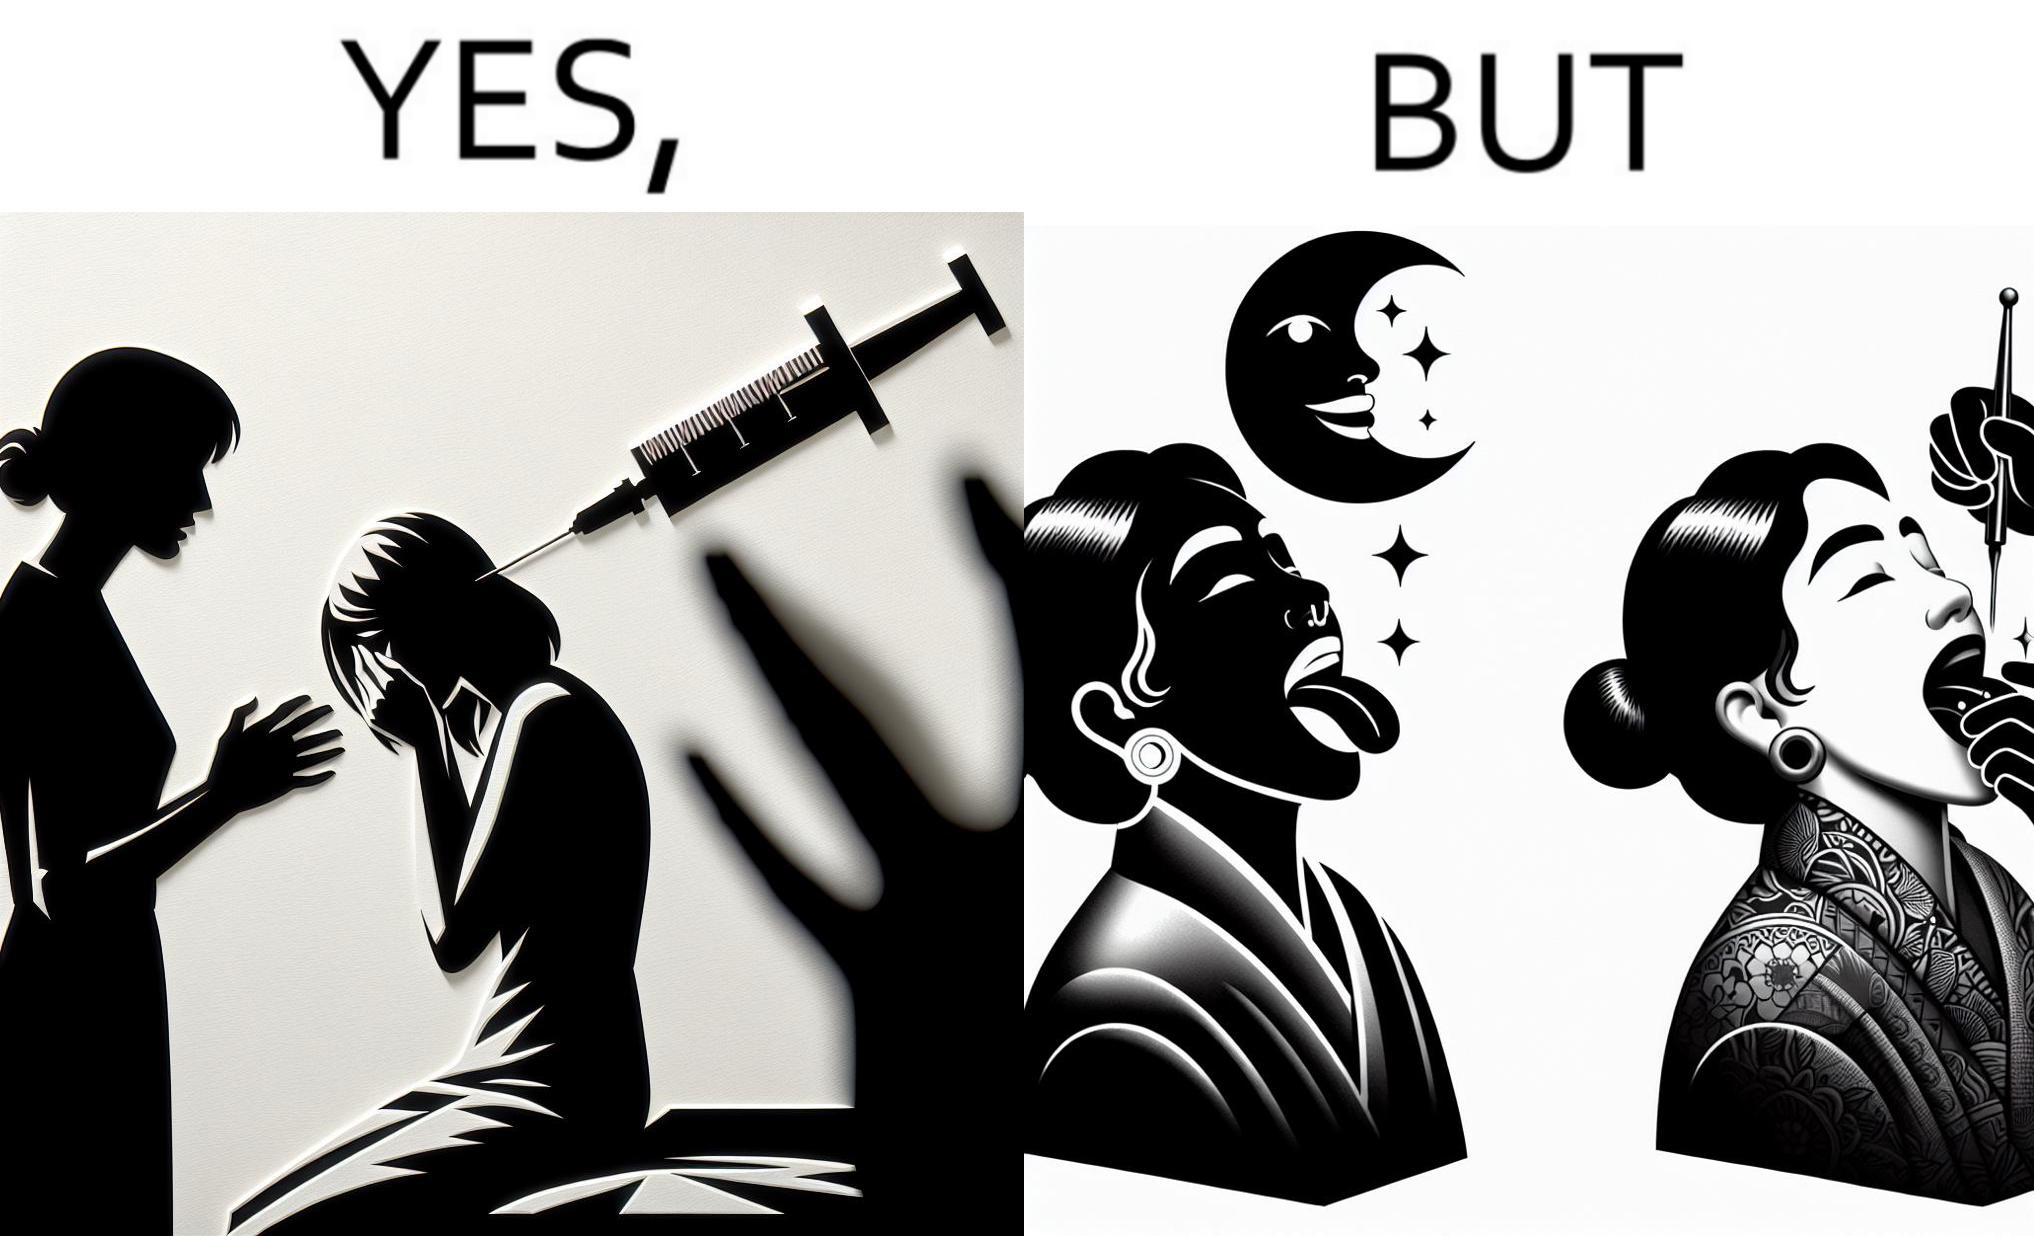Explain why this image is satirical. The image is funny becuase while the woman is scared of getting an injection which is for her benefit, she is not afraid of getting a piercing or a tattoo which are not going to help her in any way. 